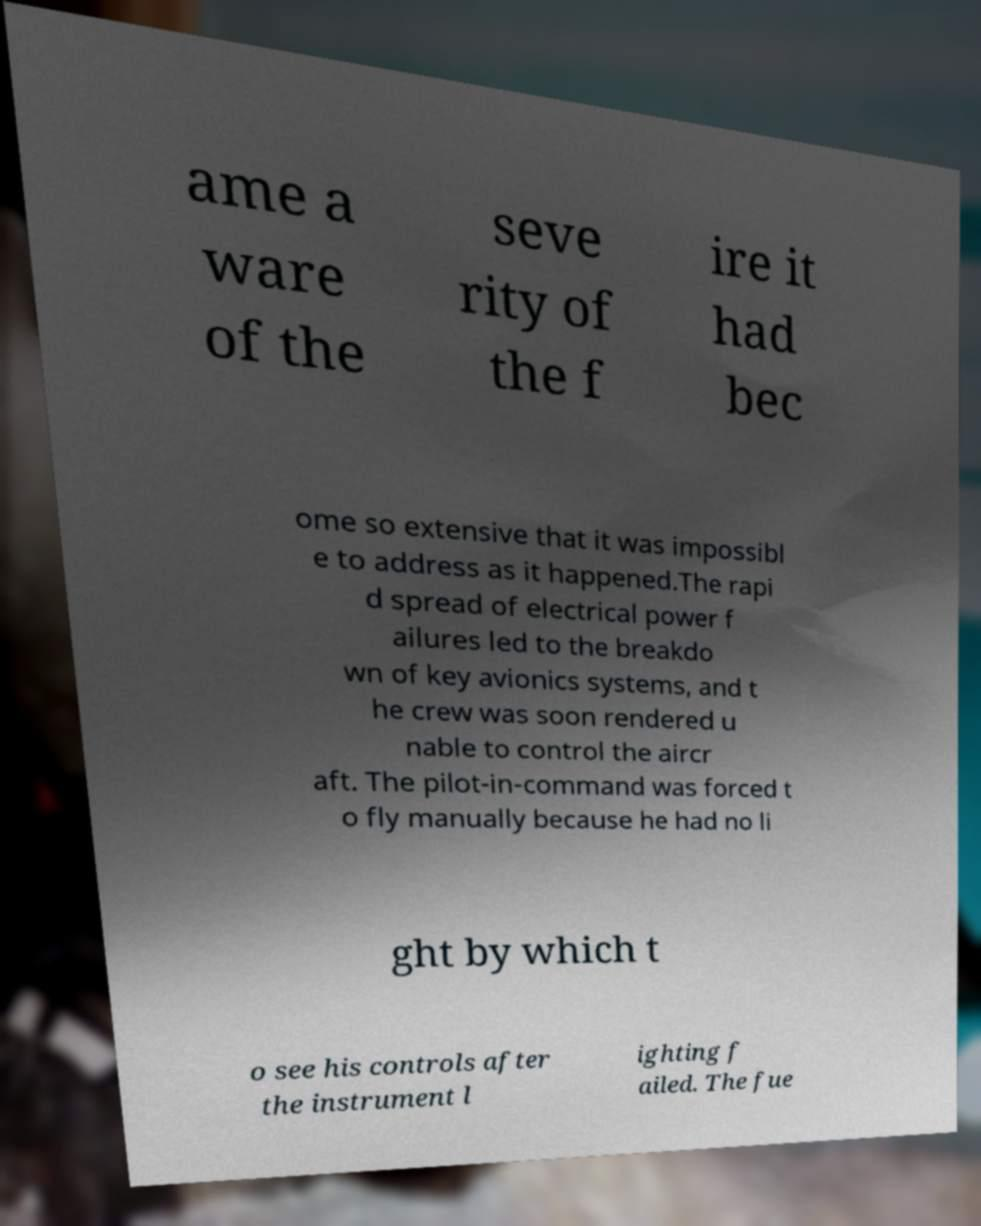There's text embedded in this image that I need extracted. Can you transcribe it verbatim? ame a ware of the seve rity of the f ire it had bec ome so extensive that it was impossibl e to address as it happened.The rapi d spread of electrical power f ailures led to the breakdo wn of key avionics systems, and t he crew was soon rendered u nable to control the aircr aft. The pilot-in-command was forced t o fly manually because he had no li ght by which t o see his controls after the instrument l ighting f ailed. The fue 